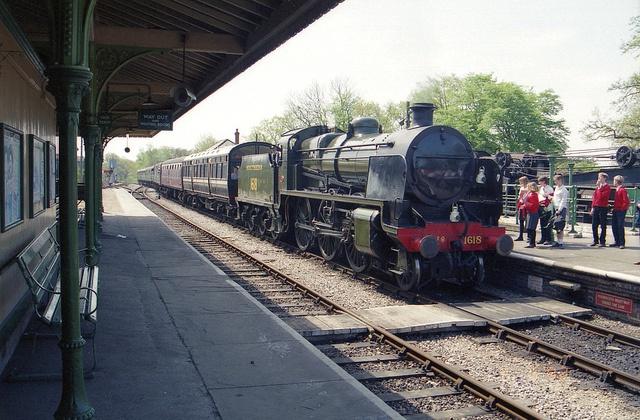Describe the objects in this image and their specific colors. I can see train in black, gray, and darkgray tones, bench in black, gray, and blue tones, people in black, darkgray, gray, and navy tones, people in black, navy, brown, and maroon tones, and people in black, maroon, navy, and brown tones in this image. 